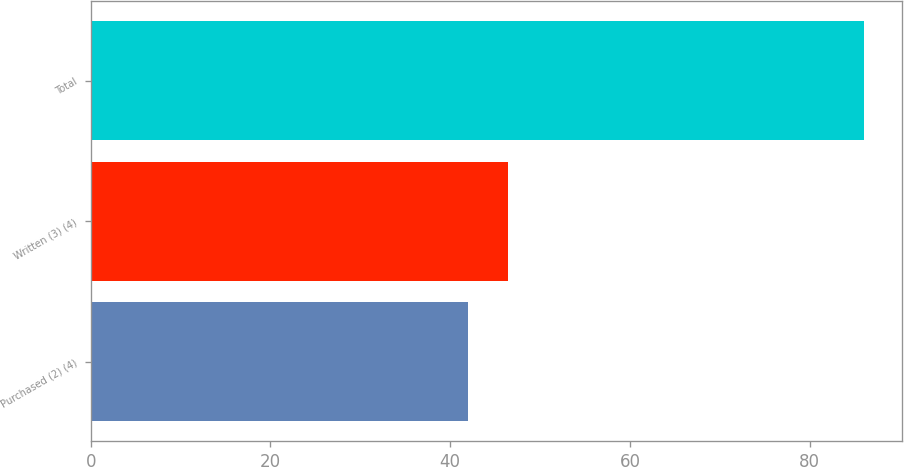Convert chart. <chart><loc_0><loc_0><loc_500><loc_500><bar_chart><fcel>Purchased (2) (4)<fcel>Written (3) (4)<fcel>Total<nl><fcel>42<fcel>46.4<fcel>86<nl></chart> 